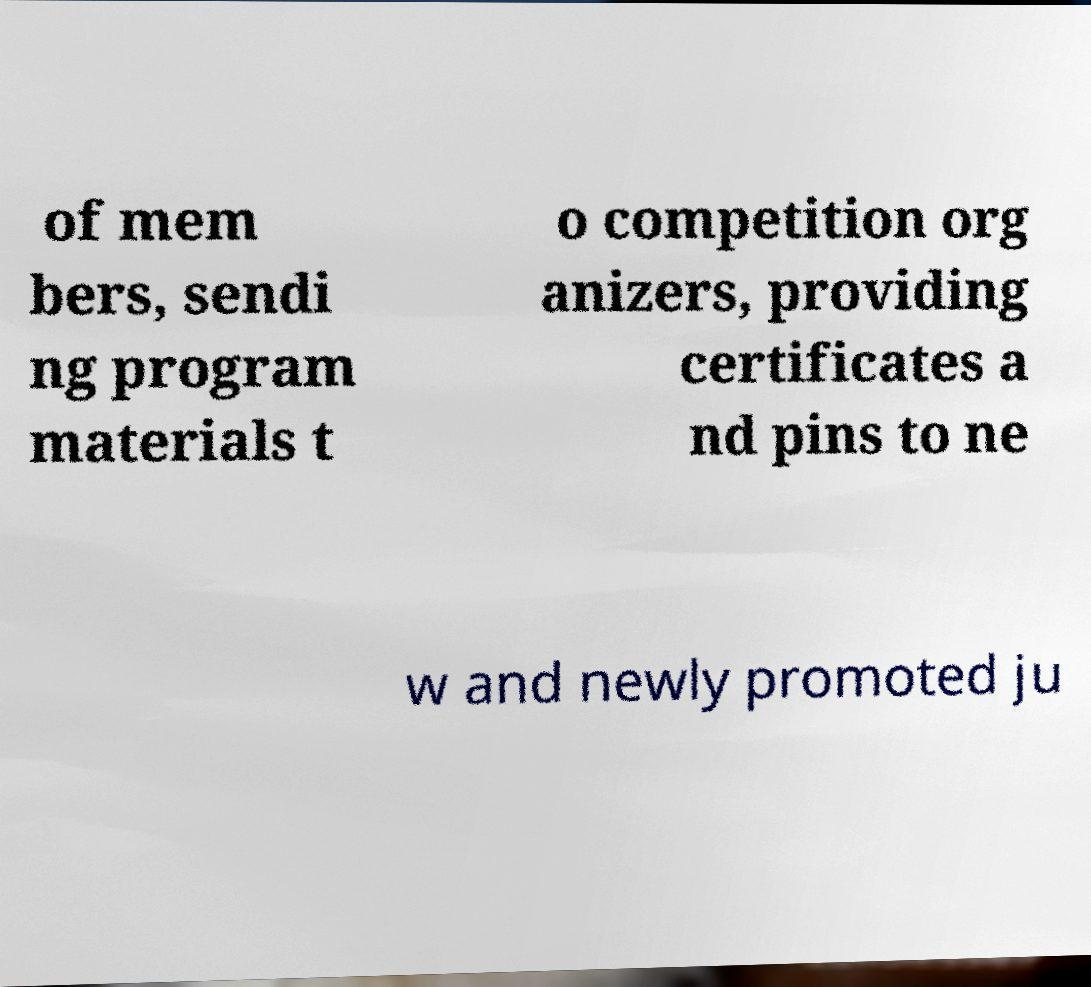Please identify and transcribe the text found in this image. of mem bers, sendi ng program materials t o competition org anizers, providing certificates a nd pins to ne w and newly promoted ju 